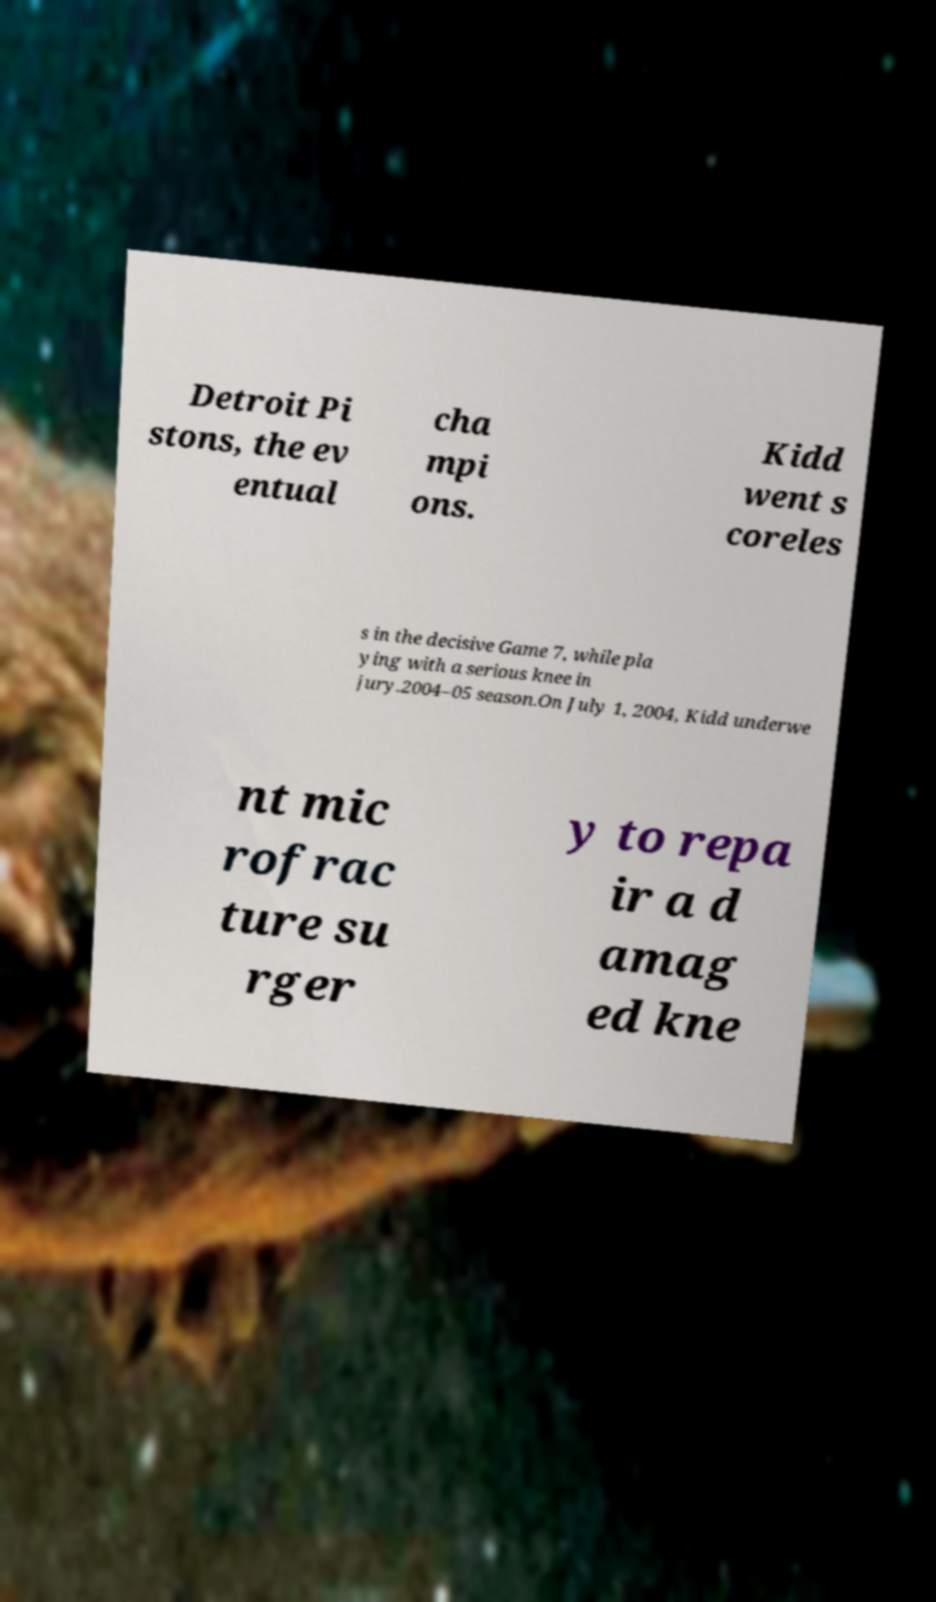Could you assist in decoding the text presented in this image and type it out clearly? Detroit Pi stons, the ev entual cha mpi ons. Kidd went s coreles s in the decisive Game 7, while pla ying with a serious knee in jury.2004–05 season.On July 1, 2004, Kidd underwe nt mic rofrac ture su rger y to repa ir a d amag ed kne 